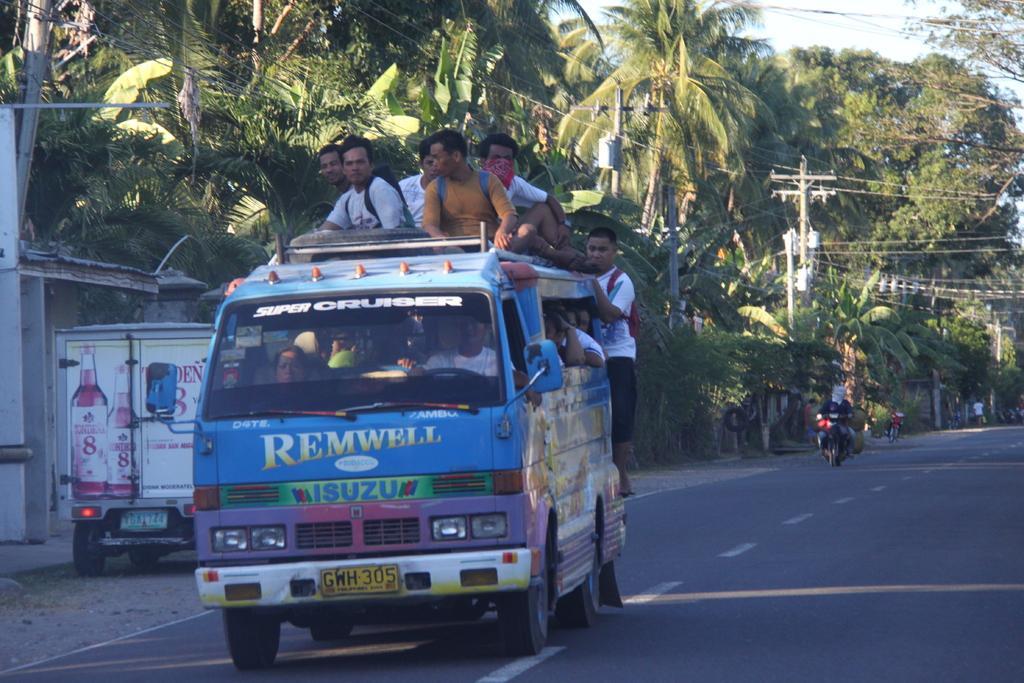Could you give a brief overview of what you see in this image? In this image there are vehicles on a road, on one vehicle there are people sitting, in the background there are trees, electrical poles and wires. 